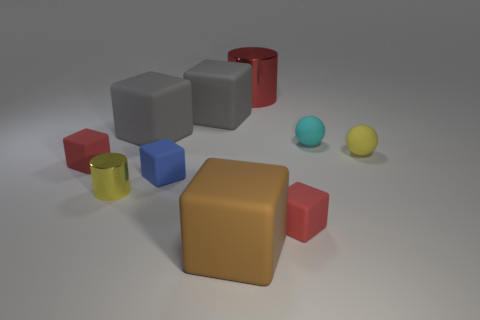Is there anything else of the same color as the big metallic cylinder?
Provide a short and direct response. Yes. The shiny object that is in front of the tiny yellow thing on the right side of the red rubber object that is right of the brown block is what shape?
Provide a succinct answer. Cylinder. What color is the other thing that is the same shape as the tiny cyan thing?
Give a very brief answer. Yellow. What color is the large rubber cube that is in front of the metallic cylinder that is on the left side of the big metallic cylinder?
Your answer should be compact. Brown. There is a yellow object that is the same shape as the cyan object; what size is it?
Offer a terse response. Small. How many yellow things are the same material as the small cylinder?
Ensure brevity in your answer.  0. There is a red block that is to the left of the tiny blue rubber cube; how many metallic cylinders are in front of it?
Provide a short and direct response. 1. Are there any cylinders left of the blue thing?
Your response must be concise. Yes. Does the large gray rubber object that is on the right side of the tiny blue rubber object have the same shape as the brown thing?
Offer a terse response. Yes. There is a small thing that is the same color as the tiny cylinder; what is it made of?
Offer a very short reply. Rubber. 